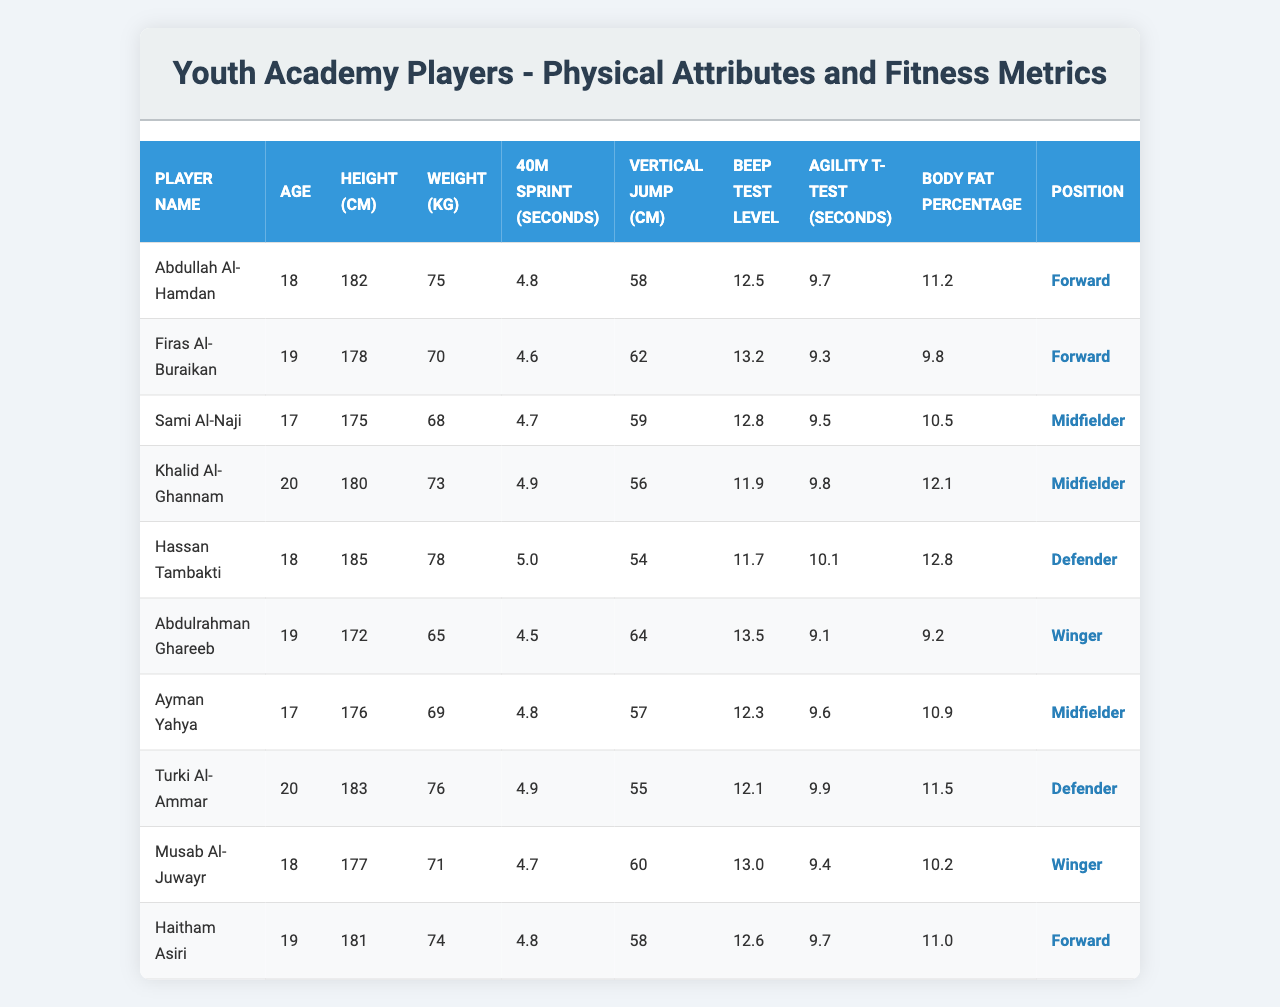What is the tallest player in the academy? The tallest player is Hassan Tambakti, who has a height of 185 cm.
Answer: 185 cm What is the average weight of the players? To calculate the average weight, we sum all players' weights: (75 + 70 + 68 + 73 + 78 + 65 + 69 + 76 + 71 + 74) =  744 kg. Dividing by the number of players (10) gives us an average weight of 74.4 kg.
Answer: 74.4 kg Who has the fastest 40m sprint time? The fastest 40m sprint time is recorded by Abdulrahman Ghareeb with a time of 4.5 seconds.
Answer: 4.5 seconds Is there a player with a body fat percentage below 10%? No, all players have a body fat percentage above 10%. The lowest is 9.2%, but it is not below 10%.
Answer: No Which player has the best vertical jump? Abdulrahman Ghareeb has the best vertical jump at 64 cm.
Answer: 64 cm What is the average age of the players? The average age is found by summing the ages: (18 + 19 + 17 + 20 + 18 + 19 + 17 + 20 + 18 + 19) = 190 years. Dividing by the number of players (10) gives us an average age of 19 years.
Answer: 19 years How many players are wingers? There are two players who are wingers: Abdulrahman Ghareeb and Musab Al-Juwayr.
Answer: 2 Which player has the highest beep test level? The player with the highest beep test level is Abdulrahman Ghareeb with a level of 13.5.
Answer: 13.5 What is the average vertical jump for all players? The average vertical jump is calculated by summing the vertical jumps: (58 + 62 + 59 + 56 + 54 + 64 + 57 + 55 + 60 + 58) =  579 cm. Dividing by the number of players (10) gives us an average of 57.9 cm.
Answer: 57.9 cm Is there a defender with an agility T-Test time above 10 seconds? Yes, both defenders (Hassan Tambakti and Turki Al-Ammar) have agility T-Test times above 10 seconds.
Answer: Yes 